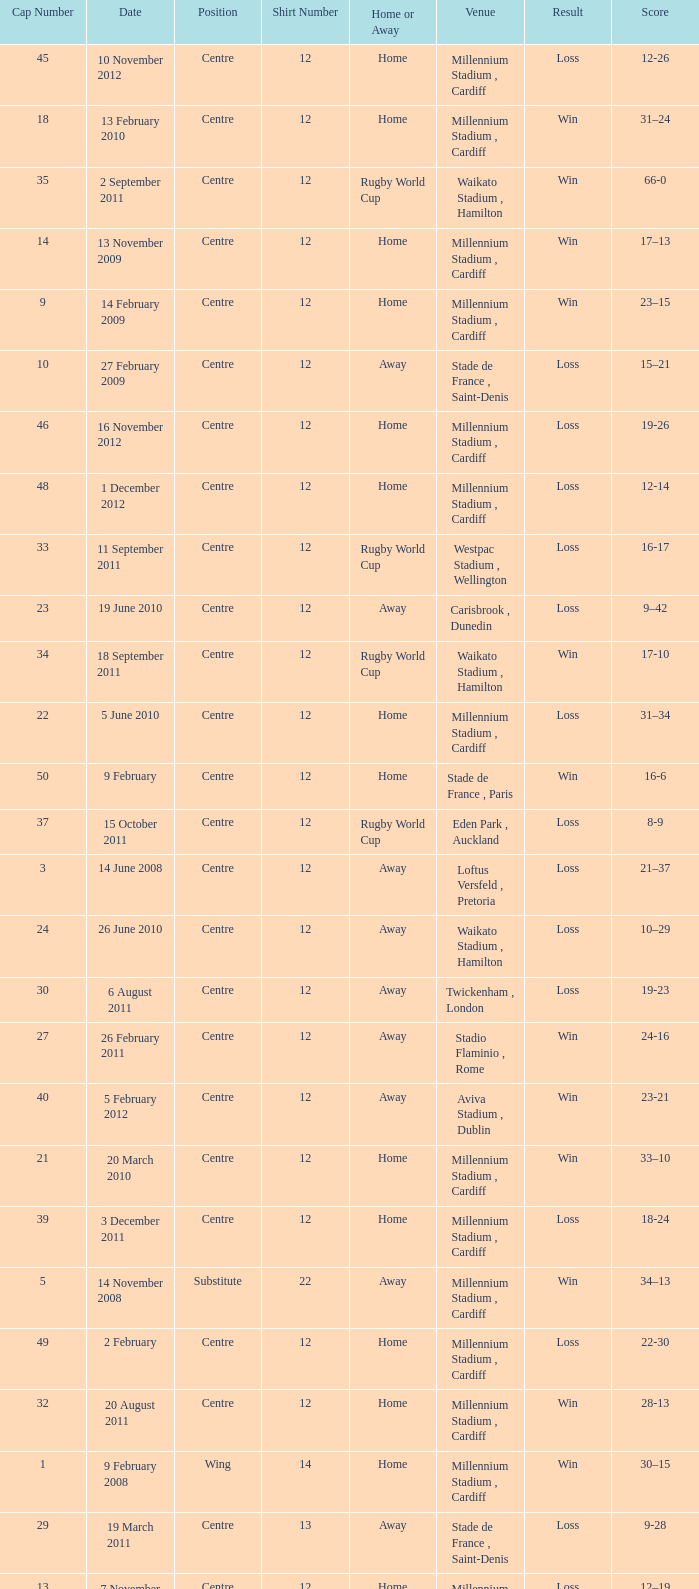What's the largest shirt number when the cap number is 5? 22.0. 